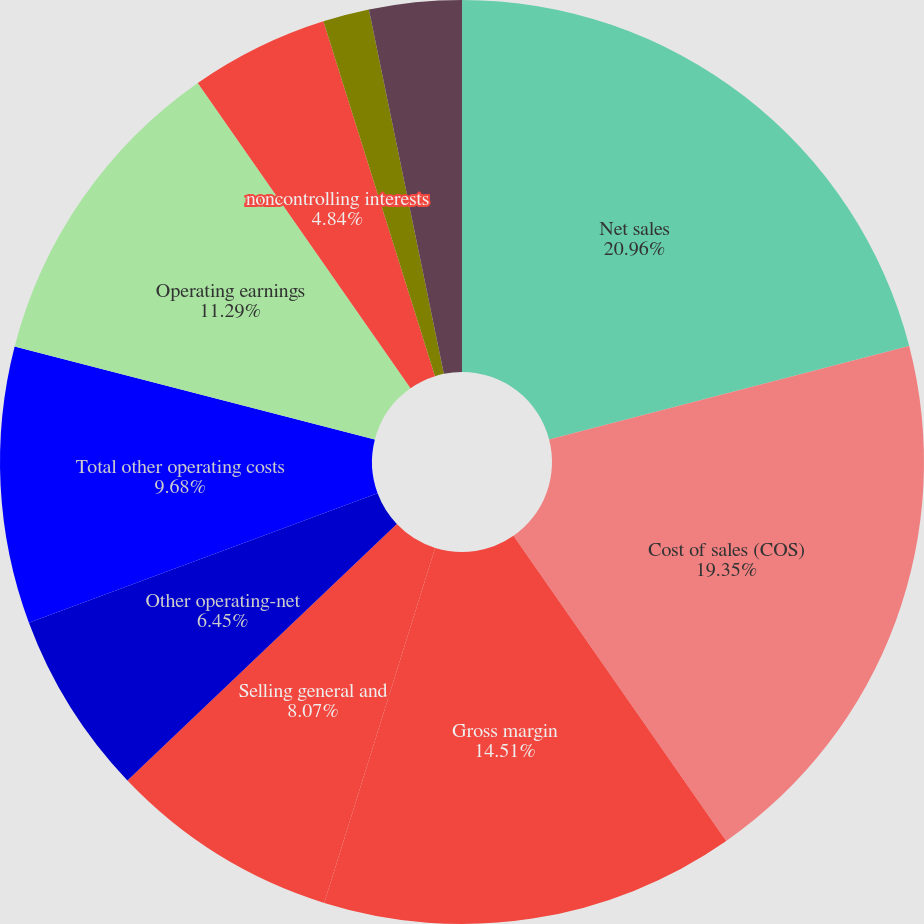Convert chart to OTSL. <chart><loc_0><loc_0><loc_500><loc_500><pie_chart><fcel>Net sales<fcel>Cost of sales (COS)<fcel>Gross margin<fcel>Selling general and<fcel>Other operating-net<fcel>Total other operating costs<fcel>Operating earnings<fcel>noncontrolling interests<fcel>Natural gas costs in COS (1)<fcel>Cost of natural gas in COS<nl><fcel>20.96%<fcel>19.35%<fcel>14.51%<fcel>8.07%<fcel>6.45%<fcel>9.68%<fcel>11.29%<fcel>4.84%<fcel>1.62%<fcel>3.23%<nl></chart> 